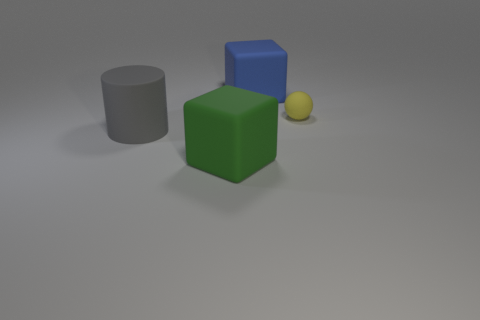Add 3 big gray cylinders. How many objects exist? 7 Subtract all cylinders. How many objects are left? 3 Subtract 1 gray cylinders. How many objects are left? 3 Subtract all matte balls. Subtract all large blue matte cubes. How many objects are left? 2 Add 1 large rubber objects. How many large rubber objects are left? 4 Add 4 big gray matte things. How many big gray matte things exist? 5 